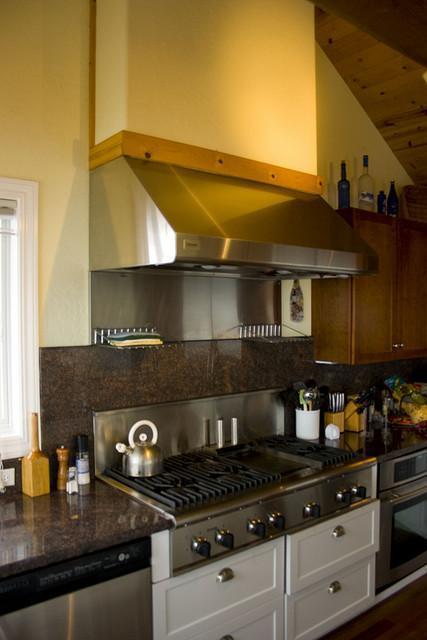How many ovens are there?
Give a very brief answer. 2. 